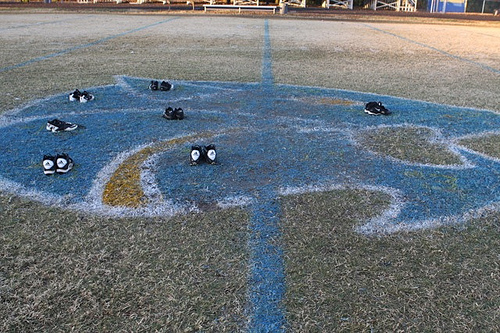<image>
Can you confirm if the sneakers is in the painting? Yes. The sneakers is contained within or inside the painting, showing a containment relationship. 